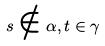<formula> <loc_0><loc_0><loc_500><loc_500>s \notin \alpha , t \in \gamma</formula> 